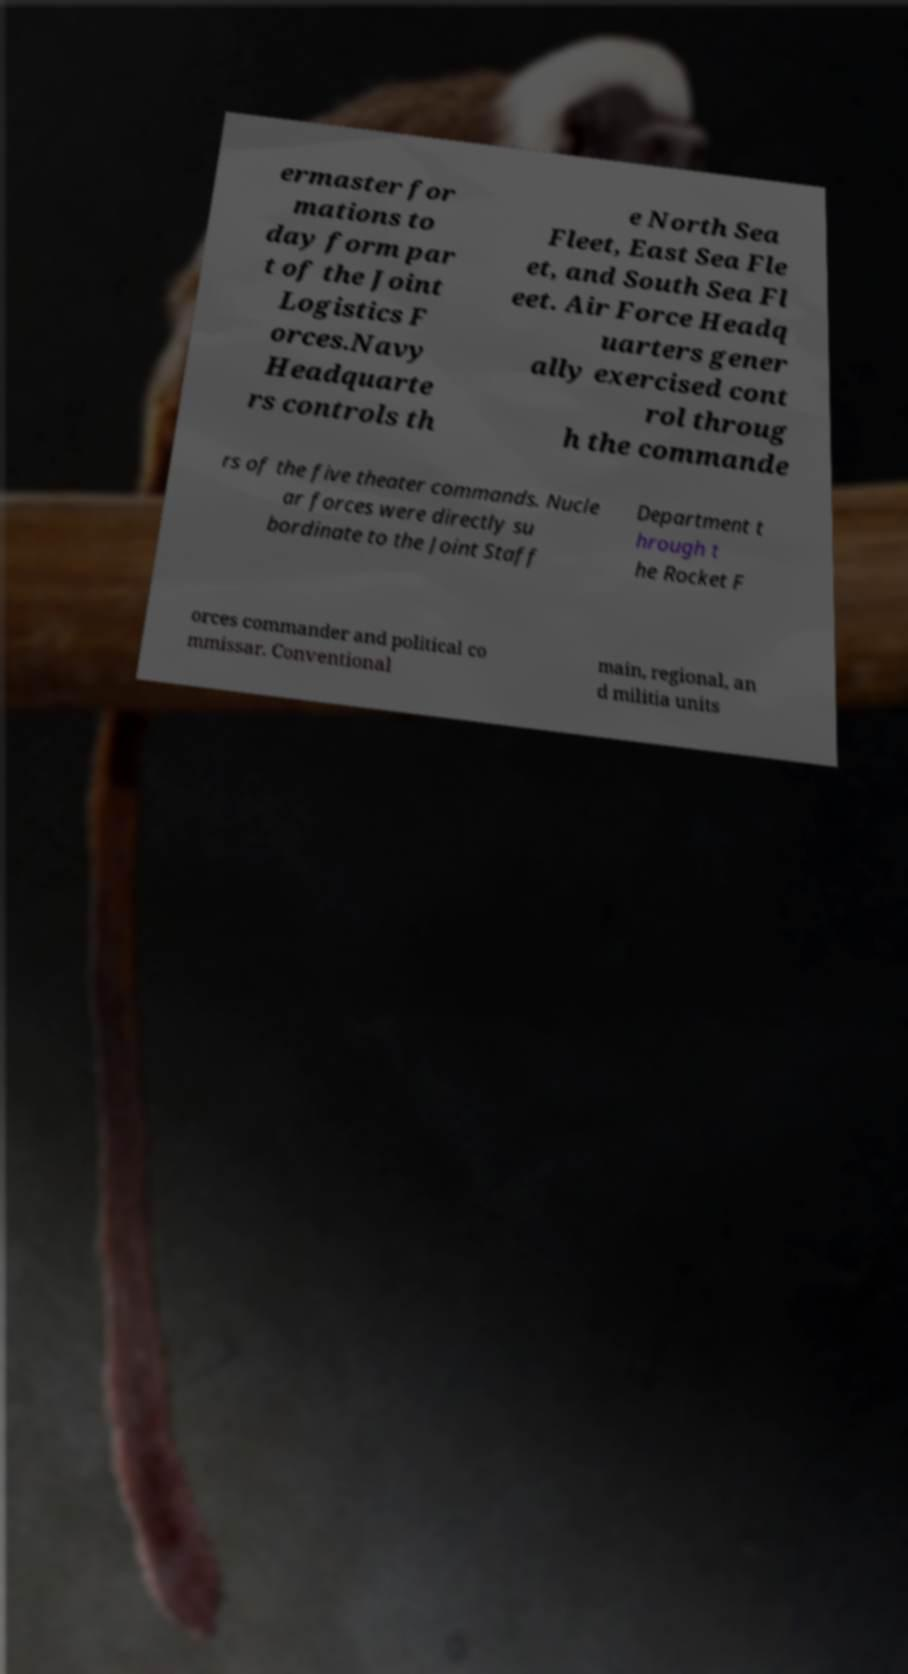Could you extract and type out the text from this image? ermaster for mations to day form par t of the Joint Logistics F orces.Navy Headquarte rs controls th e North Sea Fleet, East Sea Fle et, and South Sea Fl eet. Air Force Headq uarters gener ally exercised cont rol throug h the commande rs of the five theater commands. Nucle ar forces were directly su bordinate to the Joint Staff Department t hrough t he Rocket F orces commander and political co mmissar. Conventional main, regional, an d militia units 